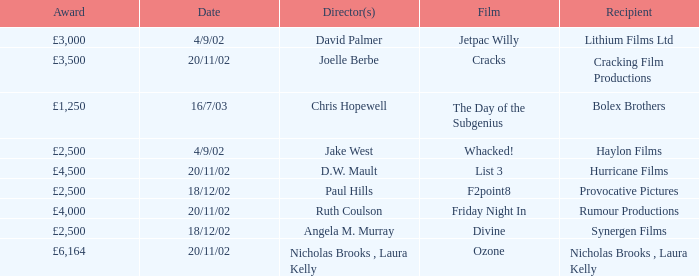Who was the director of a movie produced by cracking film productions? Joelle Berbe. 